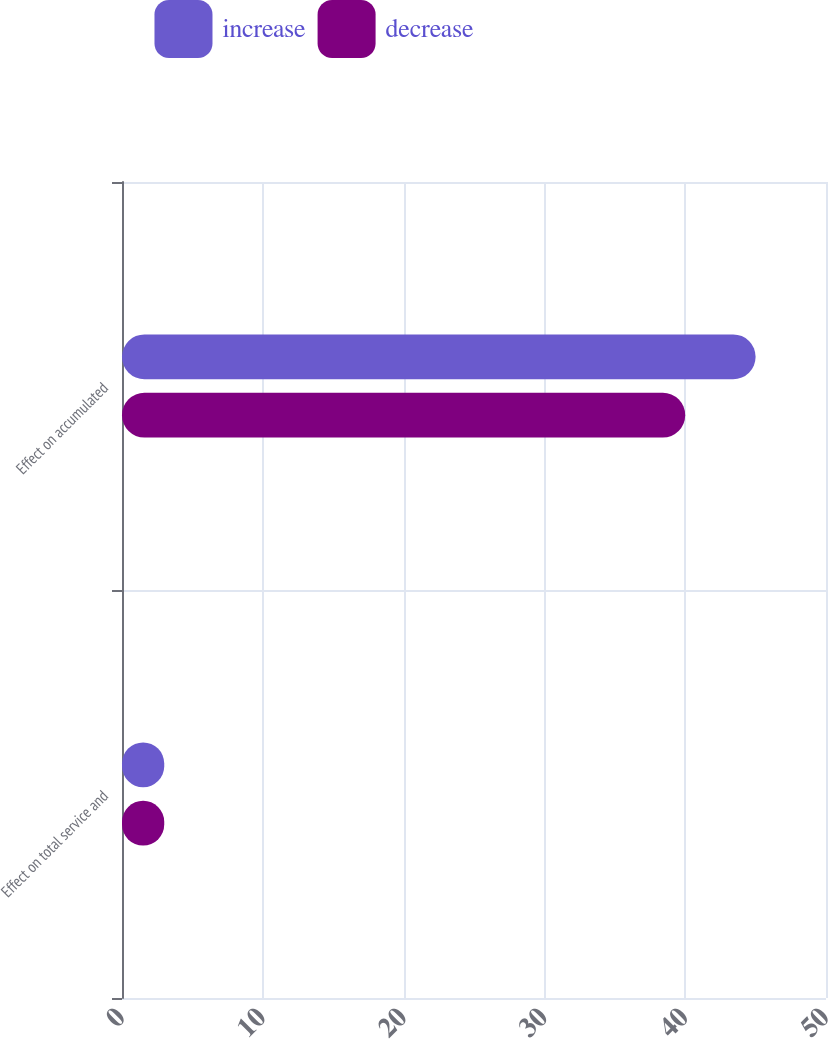Convert chart. <chart><loc_0><loc_0><loc_500><loc_500><stacked_bar_chart><ecel><fcel>Effect on total service and<fcel>Effect on accumulated<nl><fcel>increase<fcel>3<fcel>45<nl><fcel>decrease<fcel>3<fcel>40<nl></chart> 